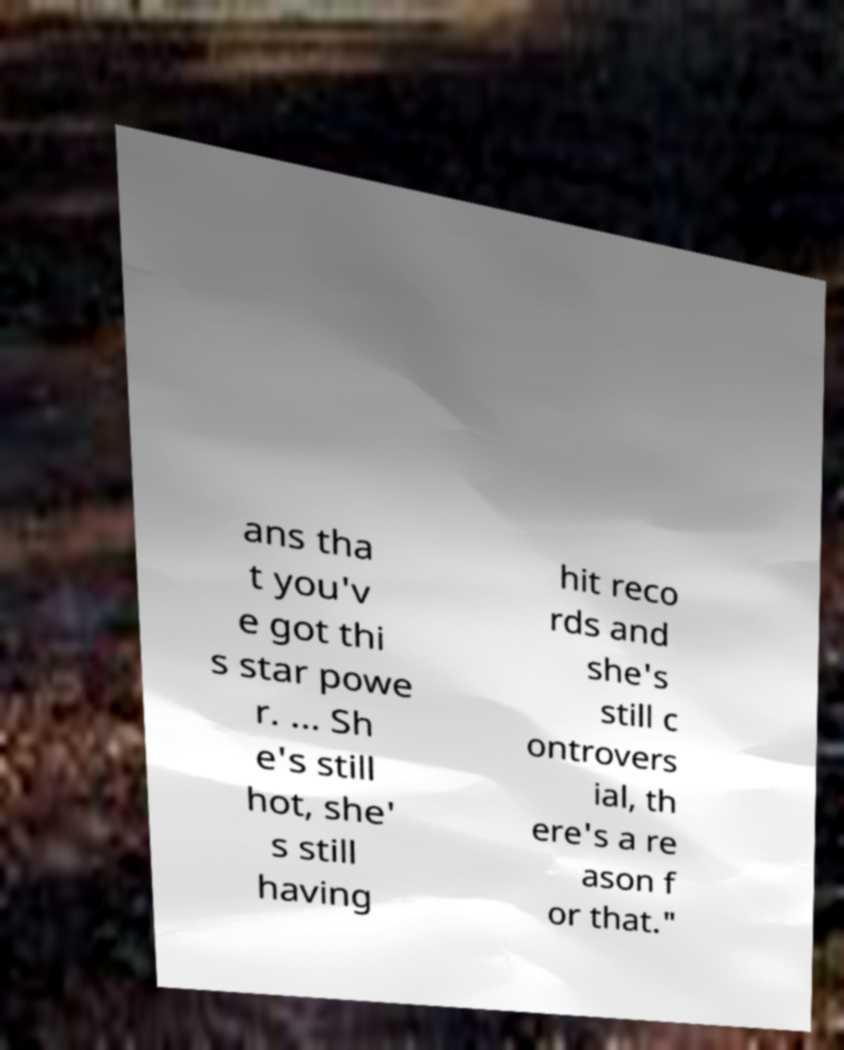Could you extract and type out the text from this image? ans tha t you'v e got thi s star powe r. ... Sh e's still hot, she' s still having hit reco rds and she's still c ontrovers ial, th ere's a re ason f or that." 